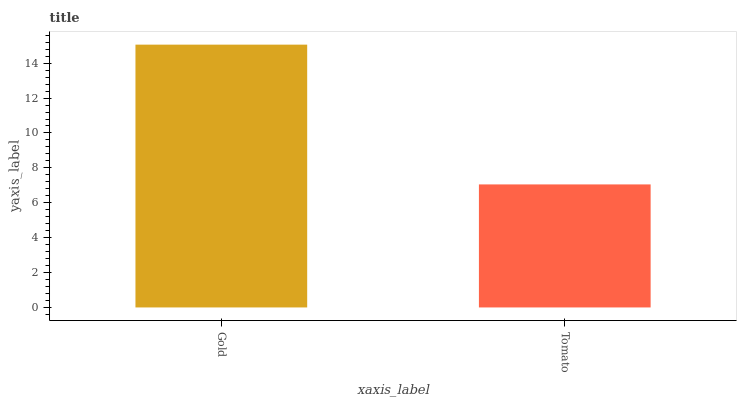Is Tomato the minimum?
Answer yes or no. Yes. Is Gold the maximum?
Answer yes or no. Yes. Is Tomato the maximum?
Answer yes or no. No. Is Gold greater than Tomato?
Answer yes or no. Yes. Is Tomato less than Gold?
Answer yes or no. Yes. Is Tomato greater than Gold?
Answer yes or no. No. Is Gold less than Tomato?
Answer yes or no. No. Is Gold the high median?
Answer yes or no. Yes. Is Tomato the low median?
Answer yes or no. Yes. Is Tomato the high median?
Answer yes or no. No. Is Gold the low median?
Answer yes or no. No. 